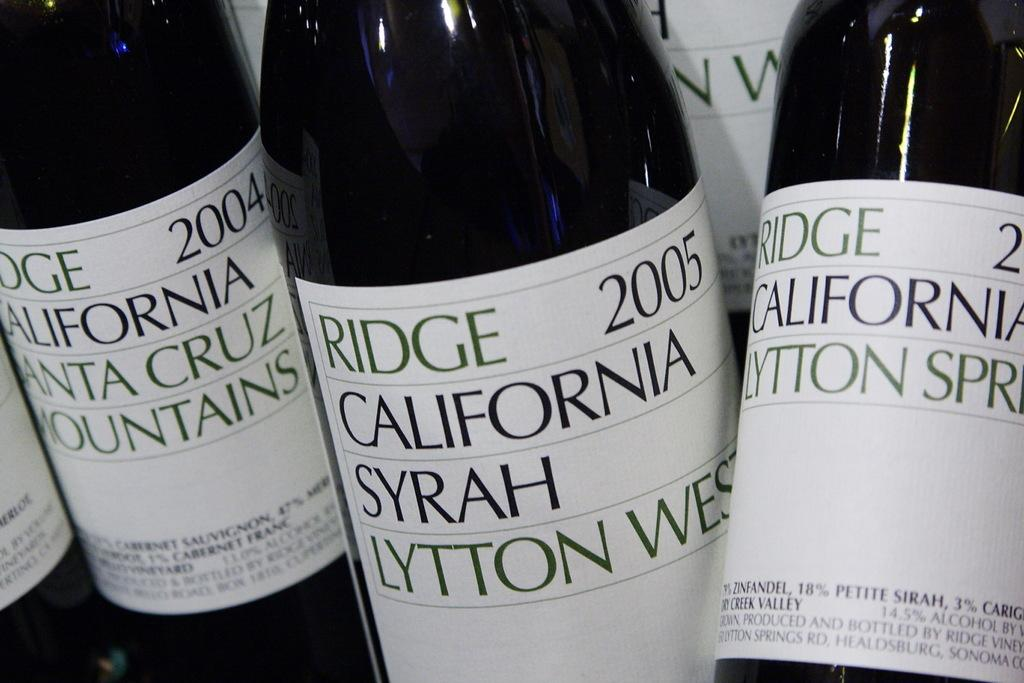<image>
Describe the image concisely. A row of wine bottles from 2004 and 2005. 